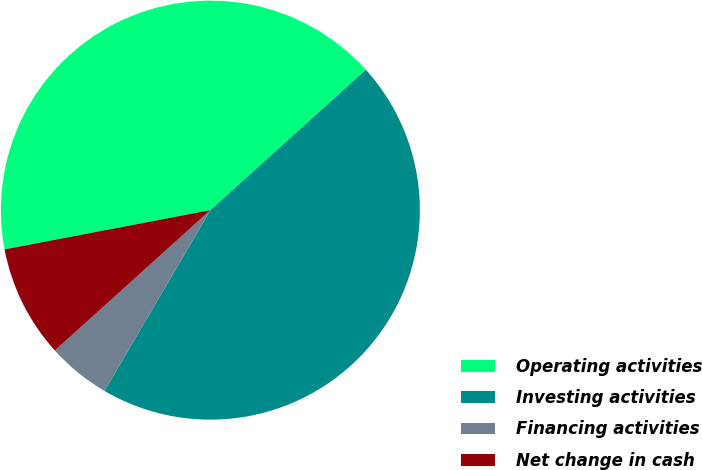Convert chart. <chart><loc_0><loc_0><loc_500><loc_500><pie_chart><fcel>Operating activities<fcel>Investing activities<fcel>Financing activities<fcel>Net change in cash<nl><fcel>41.31%<fcel>45.12%<fcel>4.88%<fcel>8.69%<nl></chart> 